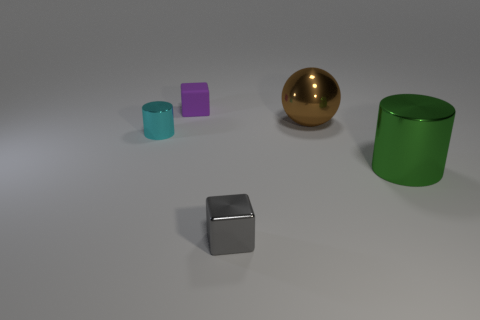Subtract 1 cubes. How many cubes are left? 1 Add 5 green things. How many objects exist? 10 Subtract all cyan cylinders. How many cylinders are left? 1 Subtract all spheres. How many objects are left? 4 Subtract 0 cyan blocks. How many objects are left? 5 Subtract all yellow blocks. Subtract all yellow cylinders. How many blocks are left? 2 Subtract all large green matte blocks. Subtract all green cylinders. How many objects are left? 4 Add 5 big brown things. How many big brown things are left? 6 Add 3 tiny cyan shiny objects. How many tiny cyan shiny objects exist? 4 